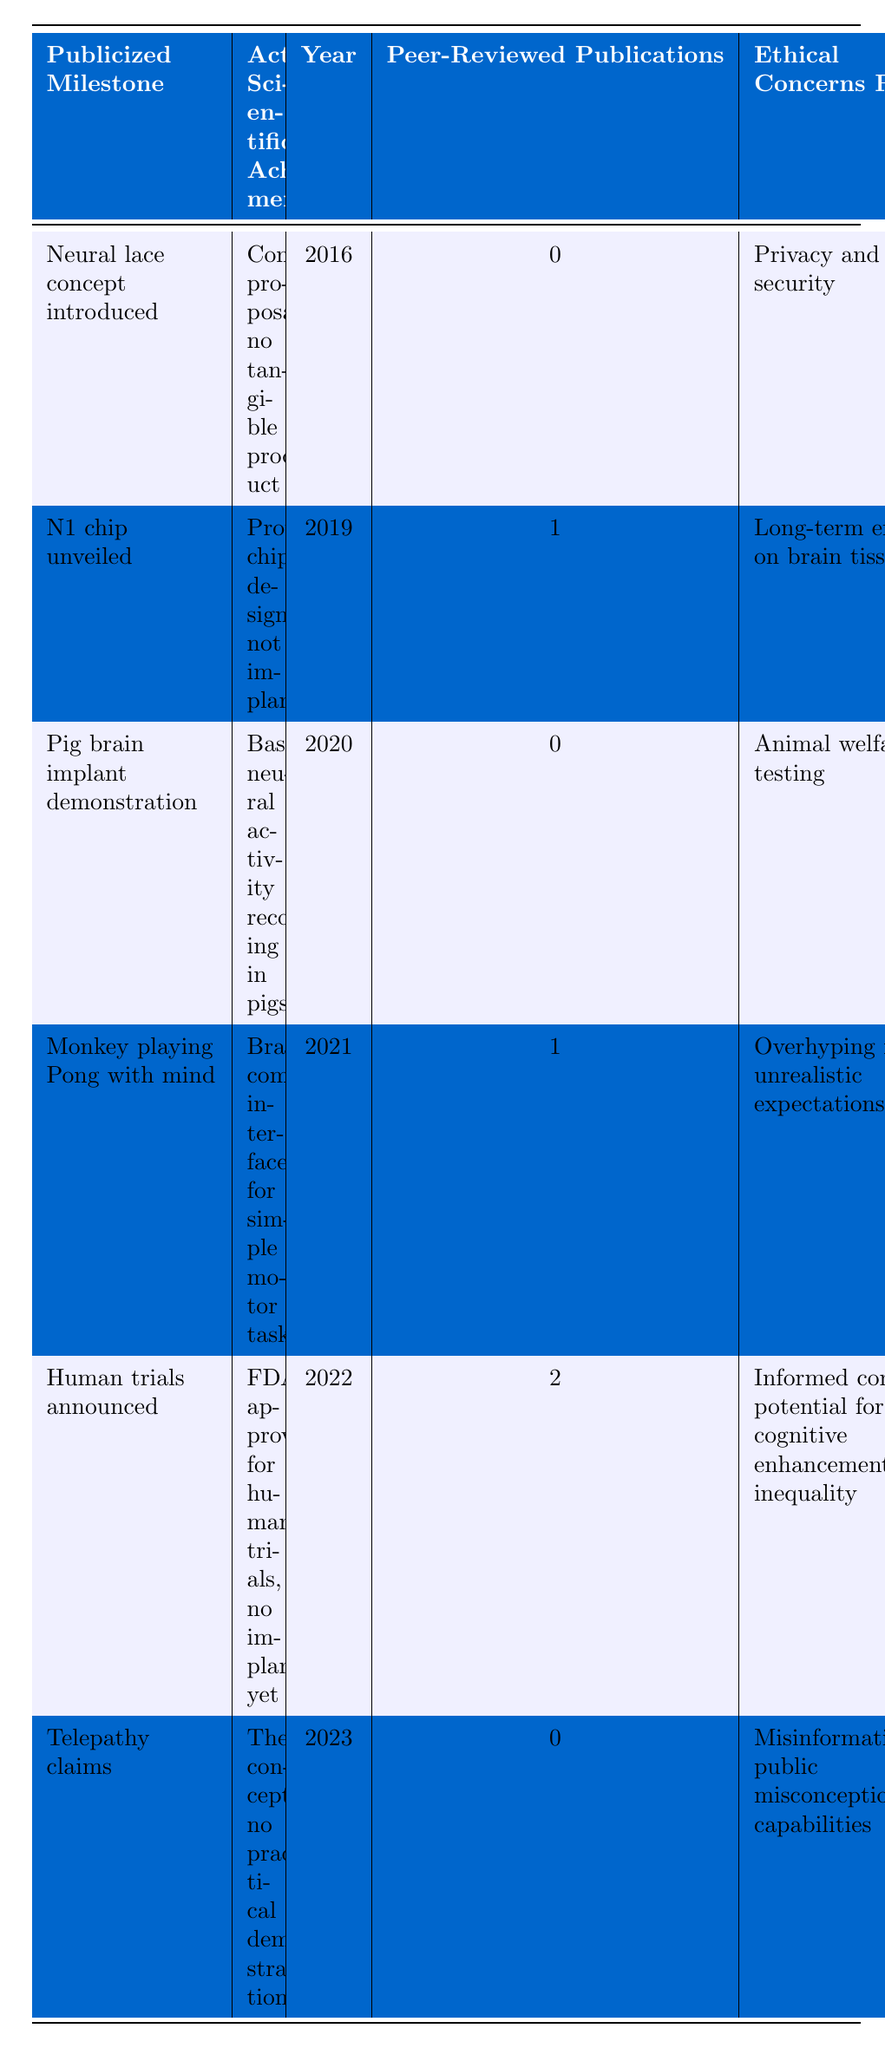What was the first publicized milestone for Neuralink? The first publicized milestone listed in the table is "Neural lace concept introduced," which occurred in the year 2016.
Answer: Neural lace concept introduced How many peer-reviewed publications resulted from the monkey playing Pong demonstration? According to the table, the monkey playing Pong with mind milestone has 1 peer-reviewed publication associated with it.
Answer: 1 Which year had the highest number of peer-reviewed publications? The table shows that the year 2022 had the highest number of peer-reviewed publications, with a total of 2.
Answer: 2022 Did Neuralink receive FDA approval for human trials in 2022? Yes, the table indicates that the milestone for human trials announced refers to FDA approval for human trials in that year.
Answer: Yes What ethical concern was raised regarding the N1 chip unveiled in 2019? The table lists "Long-term effects on brain tissue" as the ethical concern raised for the N1 chip unveiled.
Answer: Long-term effects on brain tissue In which year did Neuralink claim a pig brain implant demonstration? The demonstration involving a pig brain implant was publicized in the year 2020 as per the table.
Answer: 2020 What is the difference in the number of peer-reviewed publications between the telepathy claims and the human trials announcement? The telepathy claims have 0 peer-reviewed publications, and the human trials announcement has 2. The difference is 2 - 0 = 2.
Answer: 2 Were there any tangible products developed by Neuralink by 2016? The table states that the outcome of the neural lace concept introduced in 2016 was merely a conceptual proposal with no tangible product.
Answer: No Which publicized milestone had no peer-reviewed publications? The "Neural lace concept introduced" in 2016 and the "Pig brain implant demonstration" in 2020 both had no peer-reviewed publications.
Answer: Neural lace concept introduced, Pig brain implant demonstration What ethical concerns were raised for both the monkey playing Pong milestone and the pig brain implant demonstration? The ethical concern for the monkey playing Pong was "Overhyping results, unrealistic expectations," while for the pig brain implant it was "Animal welfare in testing." Both bring attention to ethical implications in testing and results.
Answer: Overhyping results, Animal welfare in testing 